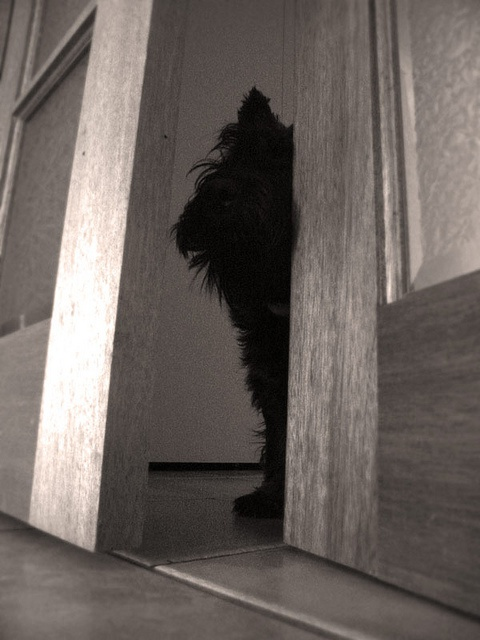Describe the objects in this image and their specific colors. I can see a dog in black and gray tones in this image. 